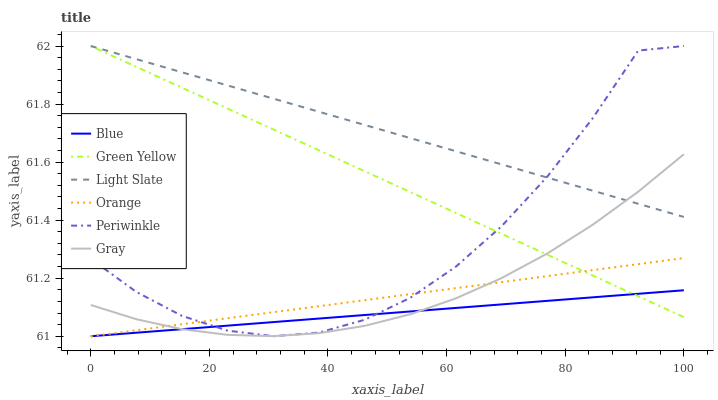Does Blue have the minimum area under the curve?
Answer yes or no. Yes. Does Light Slate have the maximum area under the curve?
Answer yes or no. Yes. Does Gray have the minimum area under the curve?
Answer yes or no. No. Does Gray have the maximum area under the curve?
Answer yes or no. No. Is Green Yellow the smoothest?
Answer yes or no. Yes. Is Periwinkle the roughest?
Answer yes or no. Yes. Is Gray the smoothest?
Answer yes or no. No. Is Gray the roughest?
Answer yes or no. No. Does Blue have the lowest value?
Answer yes or no. Yes. Does Gray have the lowest value?
Answer yes or no. No. Does Green Yellow have the highest value?
Answer yes or no. Yes. Does Gray have the highest value?
Answer yes or no. No. Is Blue less than Light Slate?
Answer yes or no. Yes. Is Light Slate greater than Blue?
Answer yes or no. Yes. Does Blue intersect Orange?
Answer yes or no. Yes. Is Blue less than Orange?
Answer yes or no. No. Is Blue greater than Orange?
Answer yes or no. No. Does Blue intersect Light Slate?
Answer yes or no. No. 